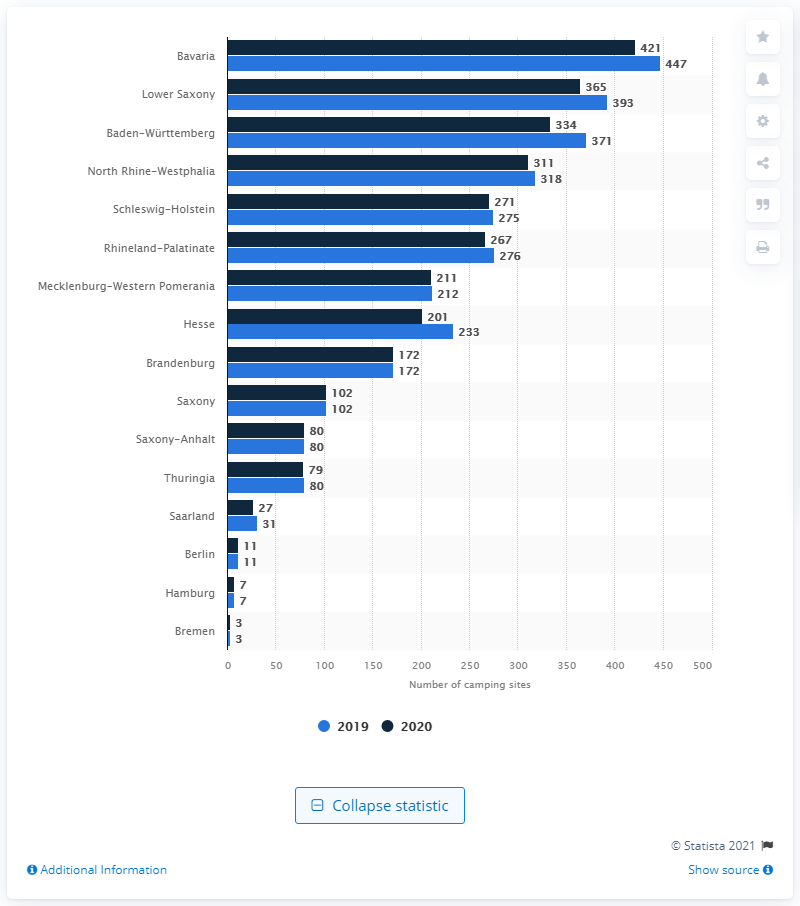What does the overall trend in the number of camping sites from 2019 to 2020 suggest about outdoor activities in Germany? The overall upward trend in the number of camping sites from 2019 to 2020 across various states in Germany suggests an increased interest in outdoor activities and possibly a greater appreciation for nature-centric vacations among the population. 